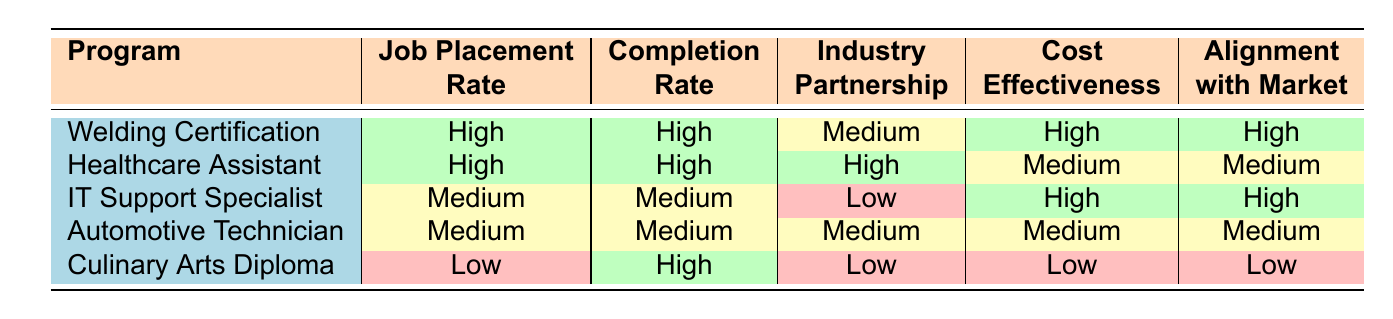What is the job placement rate for the Healthcare Assistant Training program? The table shows that the job placement rate for the Healthcare Assistant Training program is listed as 92%.
Answer: 92% Which program has the lowest job placement rate? Upon reviewing the job placement rates listed, the Culinary Arts Diploma has the lowest rate at 70%.
Answer: Culinary Arts Diploma What is the completion rate for the Automotive Technician Course? According to the table, the completion rate for the Automotive Technician Course is 75%.
Answer: 75% How many programs have a high alignment with local job market needs? The table indicates that the Welding Certification, IT Support Specialist Program, and the Healthcare Assistant Training program have high alignment, giving us a total of three programs.
Answer: 3 Is the cost-effectiveness of the IT Support Specialist Program high? The table categorizes the cost-effectiveness of the IT Support Specialist Program as high.
Answer: Yes What is the average completion rate for the programs that have a high job placement rate? The two programs with high job placement rates (Welding Certification and Healthcare Assistant Training) have completion rates of 78% and 88% respectively. Their average is (78 + 88) / 2 = 83%.
Answer: 83% Which program has both high cost-effectiveness and excellent alignment with local job market needs? Reviewing the table, the Welding Certification program meets these criteria with high cost-effectiveness and excellent alignment.
Answer: Welding Certification Is there any program with low cost-effectiveness and strong industry partnerships? By examining the table, the Culinary Arts Diploma has low cost-effectiveness, but its industry partnership strength is moderate, not strong. Therefore, no program with those criteria exists.
Answer: No What is the difference between the job placement rate of the Welding Certification and the Automotive Technician Course? The job placement rate for Welding Certification is 85%, and for Automotive Technician Course, it is 78%. The difference is 85% - 78% = 7%.
Answer: 7% What can be said about the Healthcare Assistant Training program's evaluation across all criteria? The evaluations show that Healthcare Assistant Training scored high in job placement, completion, and industry partnership, but medium in cost-effectiveness and alignment with the job market, indicating it is overall performing well but has areas for improvement.
Answer: Overall performing well, but some areas for improvement 